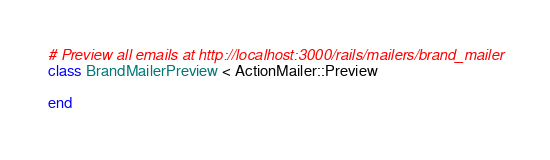<code> <loc_0><loc_0><loc_500><loc_500><_Ruby_># Preview all emails at http://localhost:3000/rails/mailers/brand_mailer
class BrandMailerPreview < ActionMailer::Preview

end
</code> 